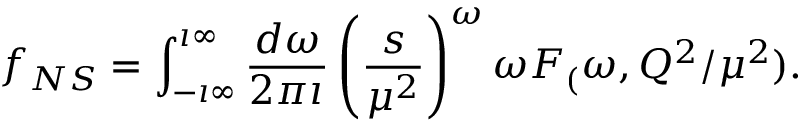Convert formula to latex. <formula><loc_0><loc_0><loc_500><loc_500>f _ { N S } = \int _ { - \imath \infty } ^ { \imath \infty } \frac { d \omega } { 2 \pi \imath } \left ( \frac { s } { \mu ^ { 2 } } \right ) ^ { \omega } \omega F _ { ( } \omega , Q ^ { 2 } / \mu ^ { 2 } ) .</formula> 